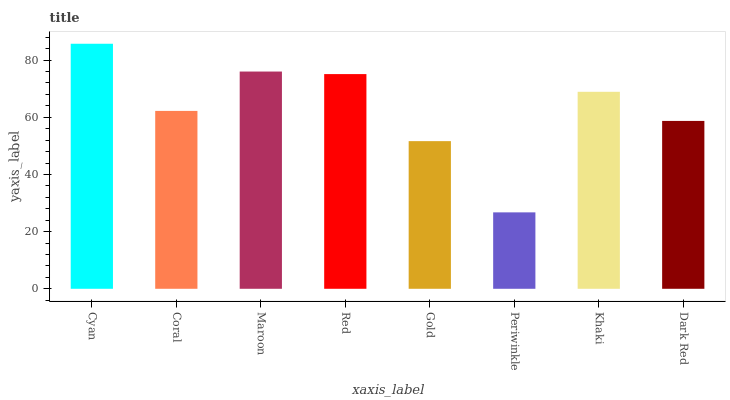Is Periwinkle the minimum?
Answer yes or no. Yes. Is Cyan the maximum?
Answer yes or no. Yes. Is Coral the minimum?
Answer yes or no. No. Is Coral the maximum?
Answer yes or no. No. Is Cyan greater than Coral?
Answer yes or no. Yes. Is Coral less than Cyan?
Answer yes or no. Yes. Is Coral greater than Cyan?
Answer yes or no. No. Is Cyan less than Coral?
Answer yes or no. No. Is Khaki the high median?
Answer yes or no. Yes. Is Coral the low median?
Answer yes or no. Yes. Is Gold the high median?
Answer yes or no. No. Is Red the low median?
Answer yes or no. No. 